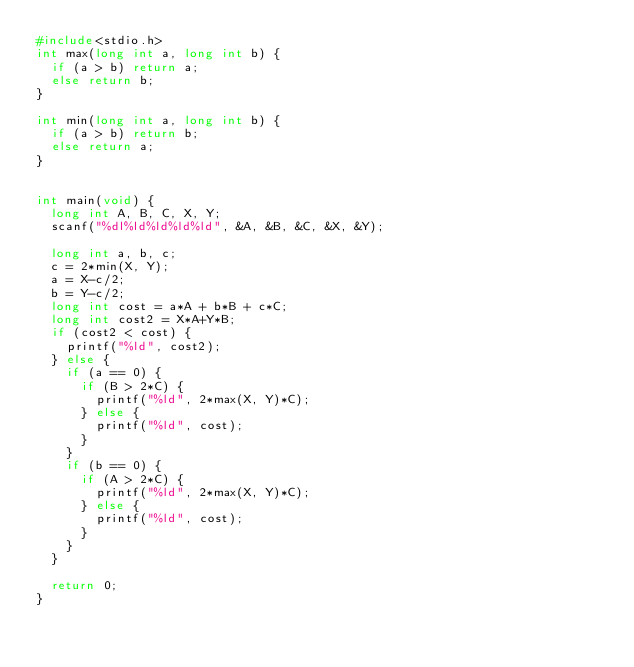Convert code to text. <code><loc_0><loc_0><loc_500><loc_500><_C_>#include<stdio.h>
int max(long int a, long int b) {
  if (a > b) return a;
  else return b;
}

int min(long int a, long int b) {
  if (a > b) return b;
  else return a;
}


int main(void) {
  long int A, B, C, X, Y;
  scanf("%dl%ld%ld%ld%ld", &A, &B, &C, &X, &Y);

  long int a, b, c;
  c = 2*min(X, Y);
  a = X-c/2;
  b = Y-c/2;
  long int cost = a*A + b*B + c*C;
  long int cost2 = X*A+Y*B;
  if (cost2 < cost) {
    printf("%ld", cost2);
  } else {
    if (a == 0) {
      if (B > 2*C) {
        printf("%ld", 2*max(X, Y)*C);
      } else {
        printf("%ld", cost);
      }
    }
    if (b == 0) {
      if (A > 2*C) {
        printf("%ld", 2*max(X, Y)*C);
      } else {
        printf("%ld", cost);
      }
    }
  }
  
  return 0;
}
</code> 